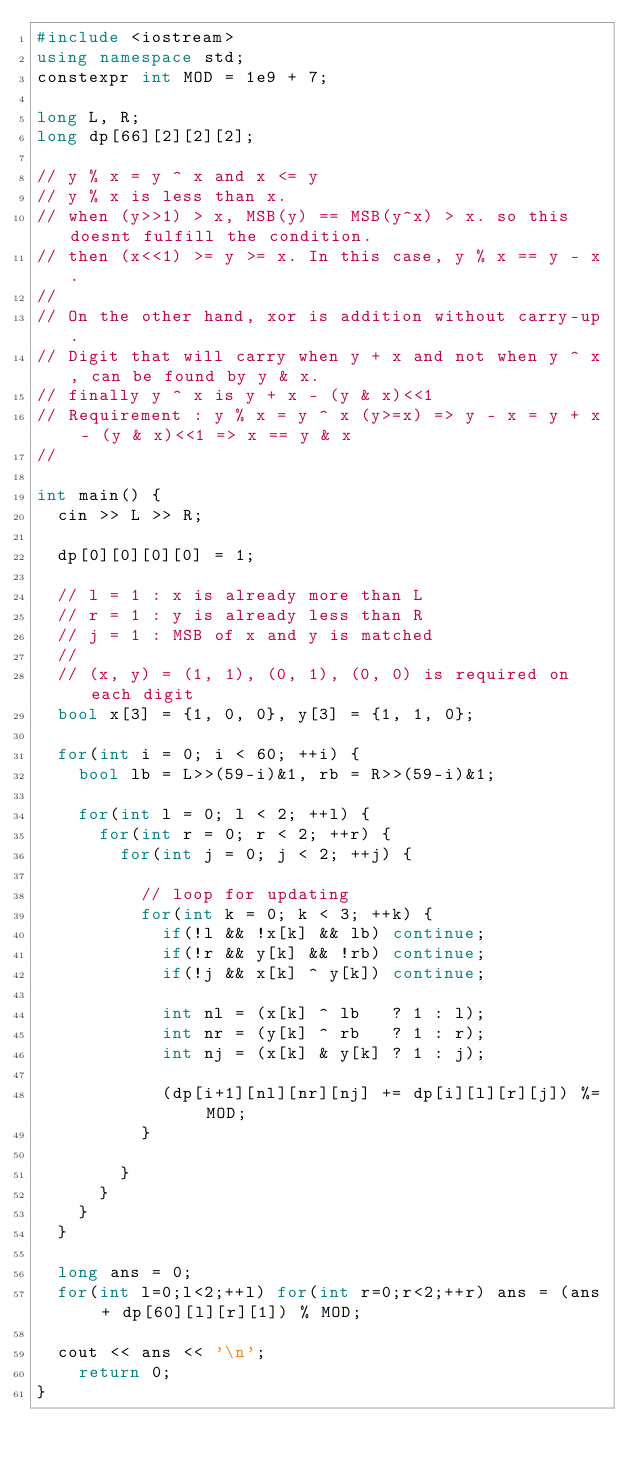Convert code to text. <code><loc_0><loc_0><loc_500><loc_500><_C++_>#include <iostream>
using namespace std;
constexpr int MOD = 1e9 + 7;

long L, R;
long dp[66][2][2][2];

// y % x = y ^ x and x <= y
// y % x is less than x. 
// when (y>>1) > x, MSB(y) == MSB(y^x) > x. so this doesnt fulfill the condition.
// then (x<<1) >= y >= x. In this case, y % x == y - x.
//
// On the other hand, xor is addition without carry-up.
// Digit that will carry when y + x and not when y ^ x, can be found by y & x.
// finally y ^ x is y + x - (y & x)<<1
// Requirement : y % x = y ^ x (y>=x) => y - x = y + x - (y & x)<<1 => x == y & x
//

int main() {
	cin >> L >> R;

	dp[0][0][0][0] = 1;
	
	// l = 1 : x is already more than L
	// r = 1 : y is already less than R
	// j = 1 : MSB of x and y is matched
	//
	// (x, y) = (1, 1), (0, 1), (0, 0) is required on each digit
	bool x[3] = {1, 0, 0}, y[3] = {1, 1, 0};

	for(int i = 0; i < 60; ++i) {
		bool lb = L>>(59-i)&1, rb = R>>(59-i)&1;

		for(int l = 0; l < 2; ++l) {
			for(int r = 0; r < 2; ++r) {
				for(int j = 0; j < 2; ++j) {

					// loop for updating
					for(int k = 0; k < 3; ++k) {
						if(!l && !x[k] && lb) continue;
						if(!r && y[k] && !rb) continue;
						if(!j && x[k] ^ y[k]) continue;
						
						int nl = (x[k] ^ lb   ? 1 : l);
						int nr = (y[k] ^ rb   ? 1 : r);
						int nj = (x[k] & y[k] ? 1 : j);

						(dp[i+1][nl][nr][nj] += dp[i][l][r][j]) %= MOD;
					}

				}
			}
		}
	}

	long ans = 0;
	for(int l=0;l<2;++l) for(int r=0;r<2;++r) ans = (ans + dp[60][l][r][1]) % MOD;

	cout << ans << '\n';
    return 0;
}
</code> 